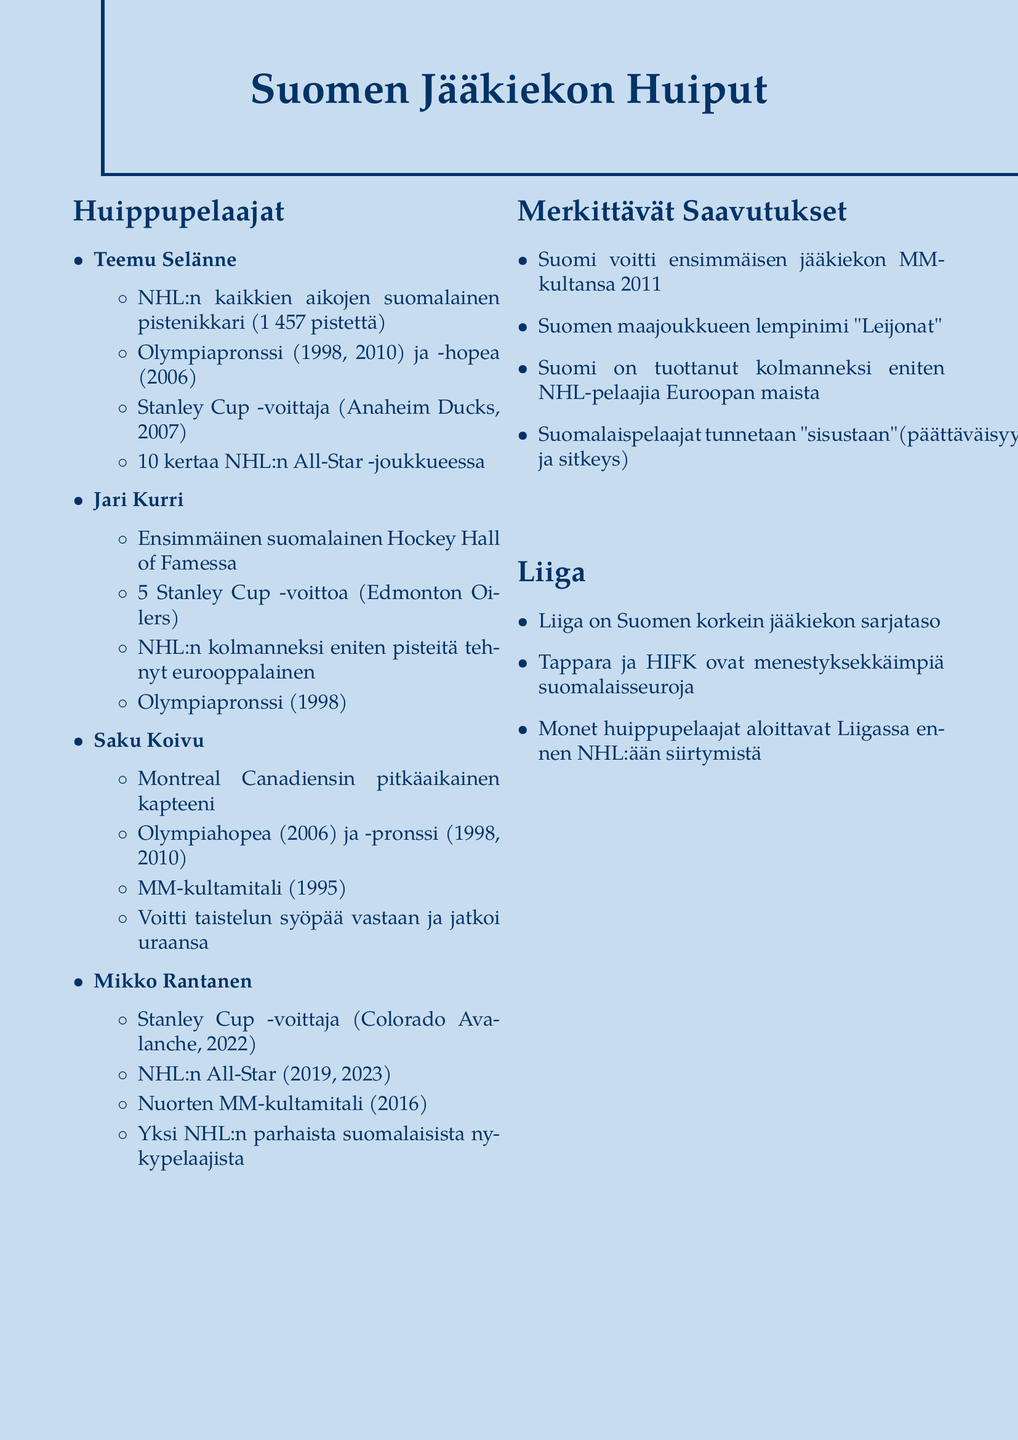what is Teemu Selänne's NHL point total? Teemu Selänne is recognized as NHL's all-time leading Finnish scorer with a total of 1,457 points.
Answer: 1,457 points how many Stanley Cups did Jari Kurri win? Jari Kurri is noted for having won five Stanley Cups with the Edmonton Oilers.
Answer: five what major illness did Saku Koivu overcome? Saku Koivu faced and overcame non-Hodgkin's lymphoma during his career.
Answer: non-Hodgkin's lymphoma which team did Mikko Rantanen win the Stanley Cup with? Mikko Rantanen won the Stanley Cup with the Colorado Avalanche in 2022.
Answer: Colorado Avalanche in which year did Finland win its first Ice Hockey World Championship gold medal? According to the notes, Finland achieved its first Ice Hockey World Championship gold medal in 2011.
Answer: 2011 what is the nickname of the Finnish national hockey team? The Finnish national team is nicknamed "Leijonat" (The Lions).
Answer: Leijonat how many times was Teemu Selänne selected as an NHL All-Star? Teemu Selänne was selected as an NHL All-Star ten times in his career.
Answer: 10 times what league is considered the top professional ice hockey league in Finland? The top professional ice hockey league in Finland is referred to as Liiga.
Answer: Liiga which two clubs are mentioned as successful Finnish teams? Tappara and HIFK are highlighted as among the most successful Finnish club teams in the document.
Answer: Tappara and HIFK 